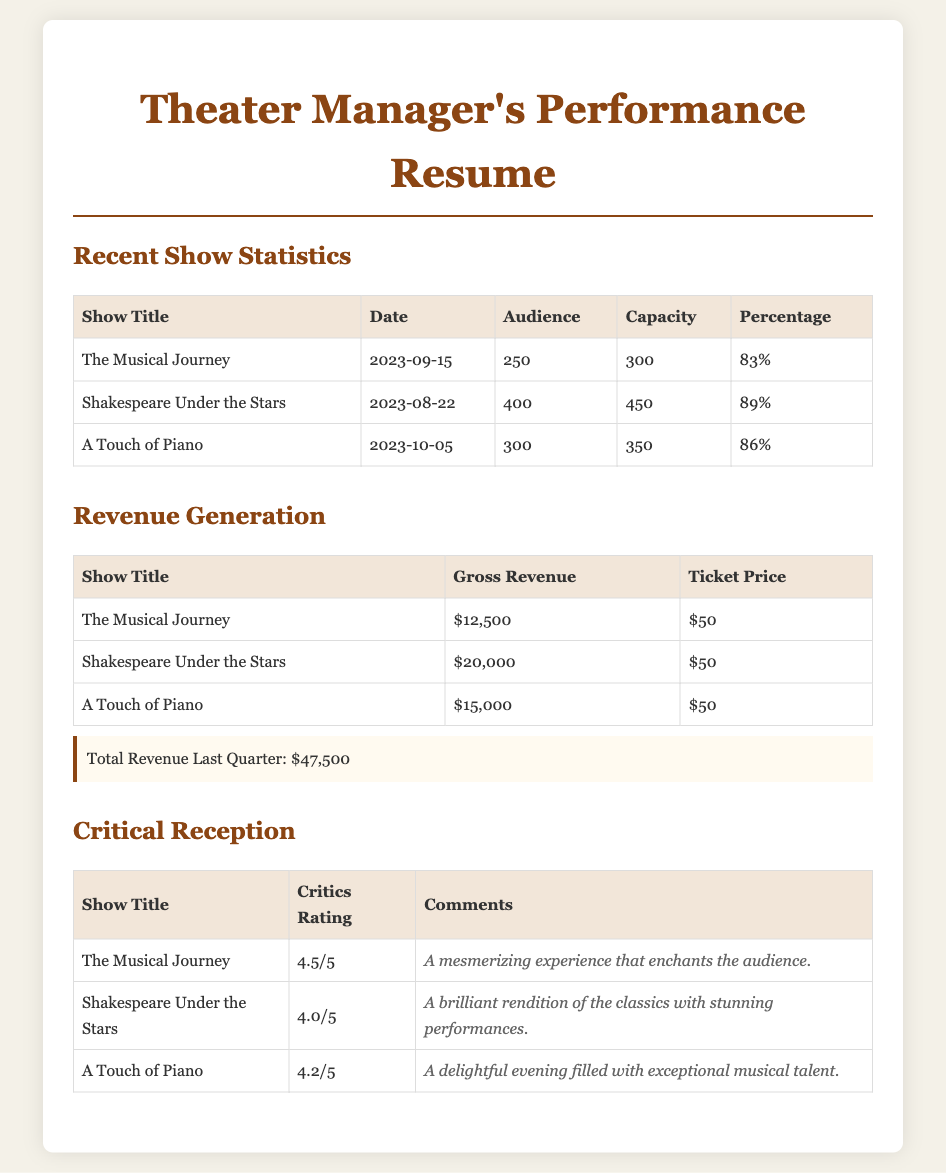What is the date of "Shakespeare Under the Stars"? The date for "Shakespeare Under the Stars" is provided in the document under the Recent Show Statistics section, specifically listed as 2023-08-22.
Answer: 2023-08-22 What was the audience turnout for "A Touch of Piano"? The audience turnout for "A Touch of Piano" is indicated in the Recent Show Statistics section as 300 attending.
Answer: 300 What is the gross revenue generated by "The Musical Journey"? The gross revenue for "The Musical Journey" is presented in the Revenue Generation section as $12,500.
Answer: $12,500 Which show received a critics rating of 4.5/5? The show that received a critics rating of 4.5/5 is mentioned in the Critical Reception section, which lists "The Musical Journey."
Answer: The Musical Journey What is the total capacity for "Shakespeare Under the Stars"? The total capacity for "Shakespeare Under the Stars" can be found in the Recent Show Statistics section and is recorded as 450.
Answer: 450 How many shows had an audience percentage above 85%? By analyzing the audience percentages in the Recent Show Statistics section, two shows, "Shakespeare Under the Stars" and "A Touch of Piano," had percentages above 85%.
Answer: 2 What is the average critics rating of the recent shows? The average critics rating is derived from the ratings of the three shows: (4.5 + 4.0 + 4.2) / 3, which gives a result noted in the document as approximately 4.23.
Answer: 4.23 What was the ticket price for all the shows? The ticket price for all the shows is consistently listed in the Revenue Generation section as $50.
Answer: $50 